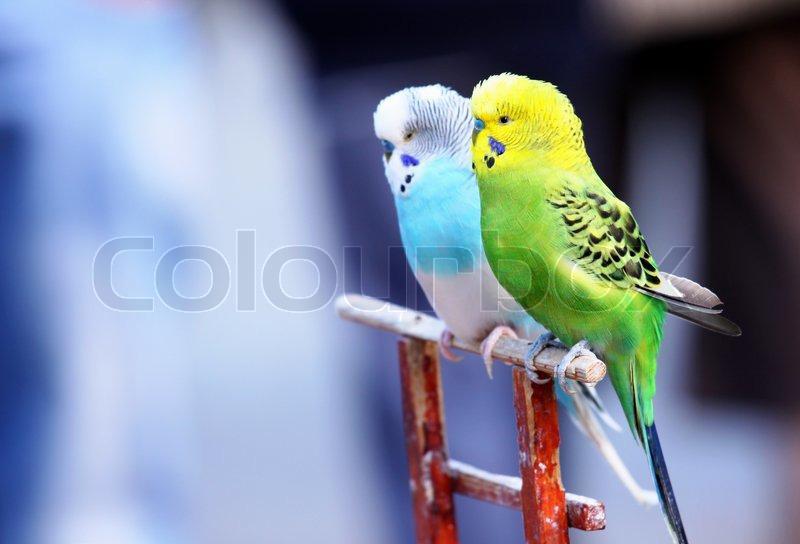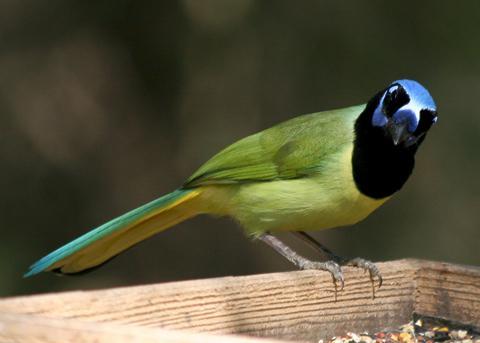The first image is the image on the left, the second image is the image on the right. Examine the images to the left and right. Is the description "There are three birds" accurate? Answer yes or no. Yes. 